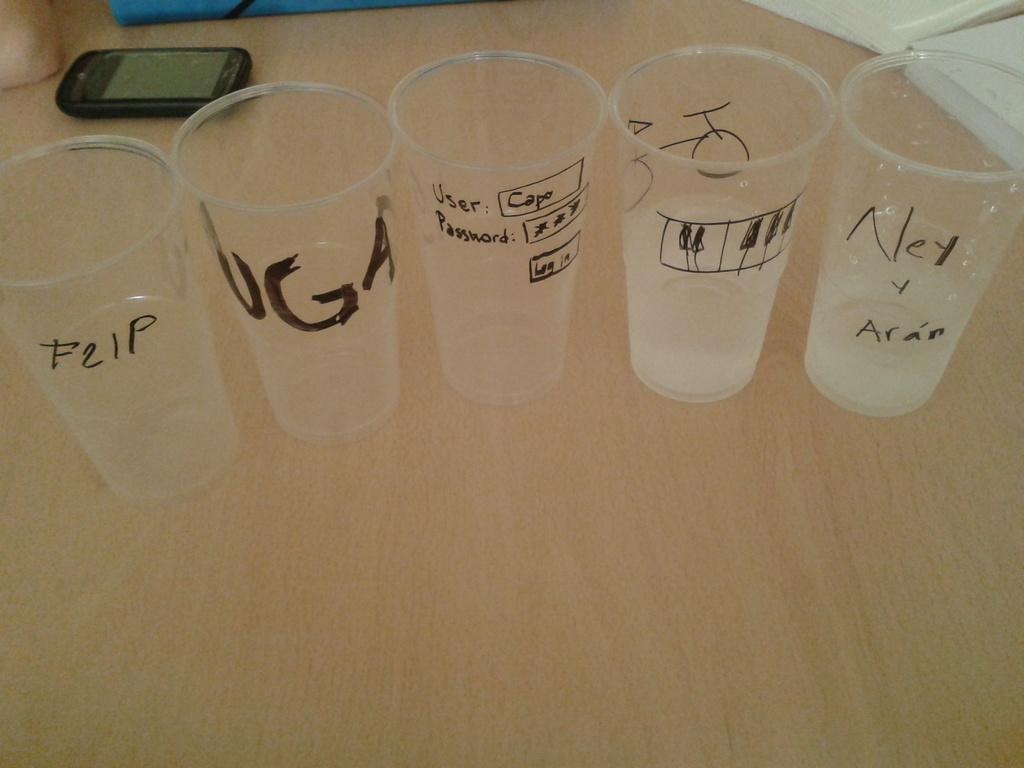<image>
Describe the image concisely. Clear cups are on a table with a piano keyboard on one and a password on another. 